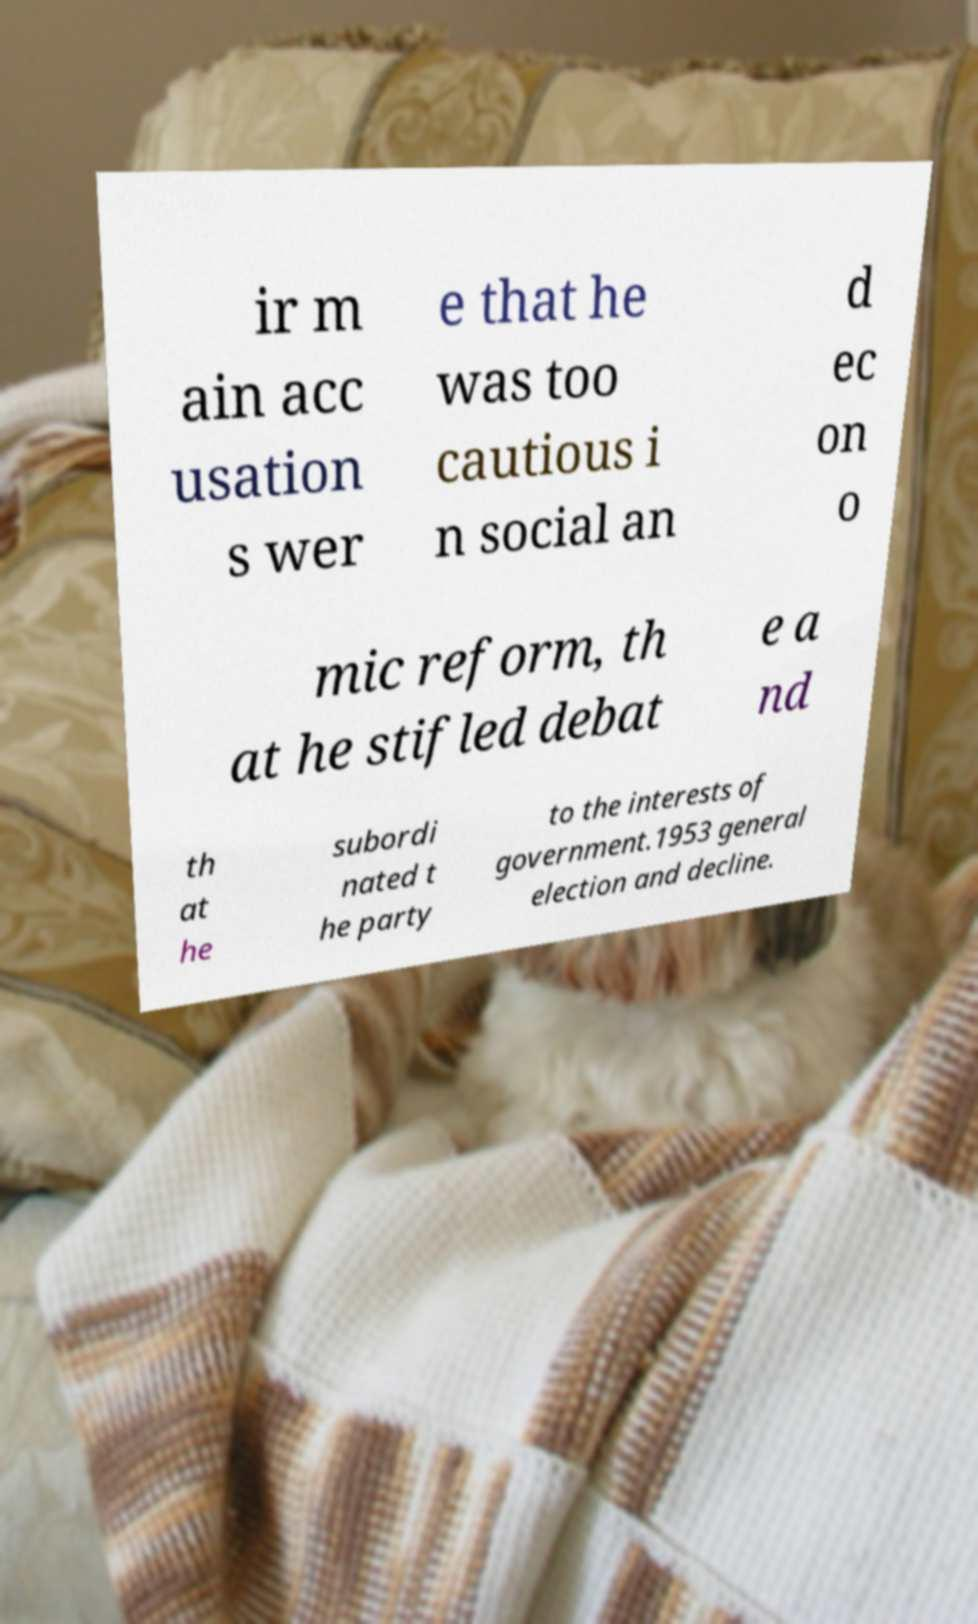I need the written content from this picture converted into text. Can you do that? ir m ain acc usation s wer e that he was too cautious i n social an d ec on o mic reform, th at he stifled debat e a nd th at he subordi nated t he party to the interests of government.1953 general election and decline. 